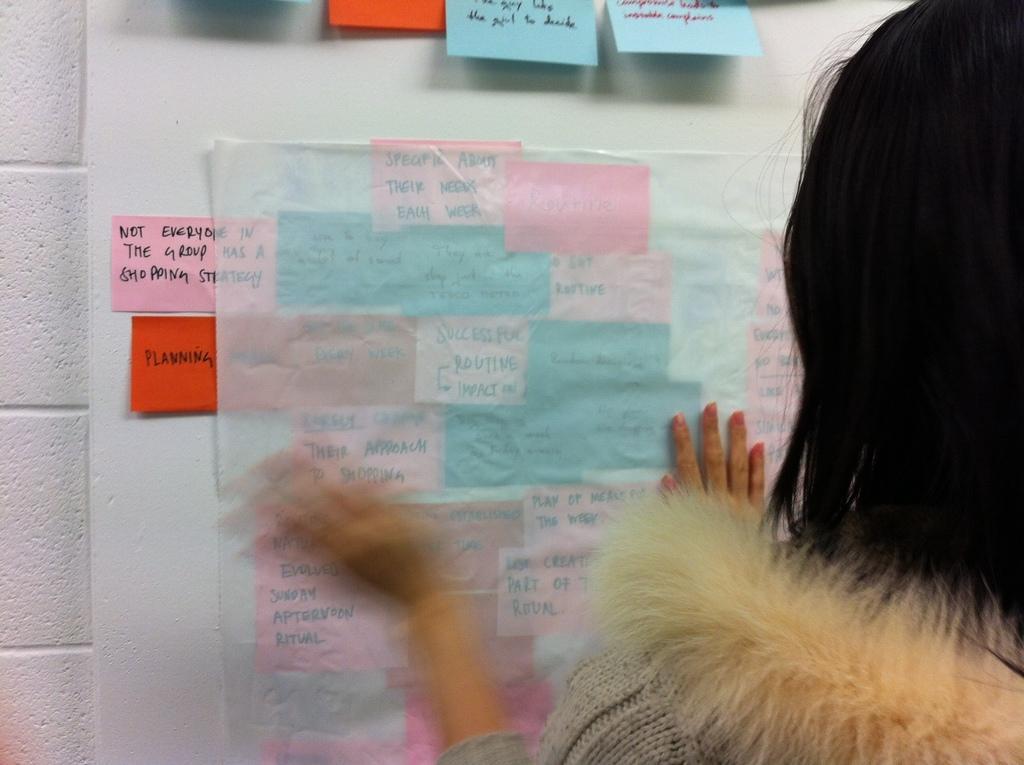Can you describe this image briefly? In this image I can a lady sticking somethings on the wall. 